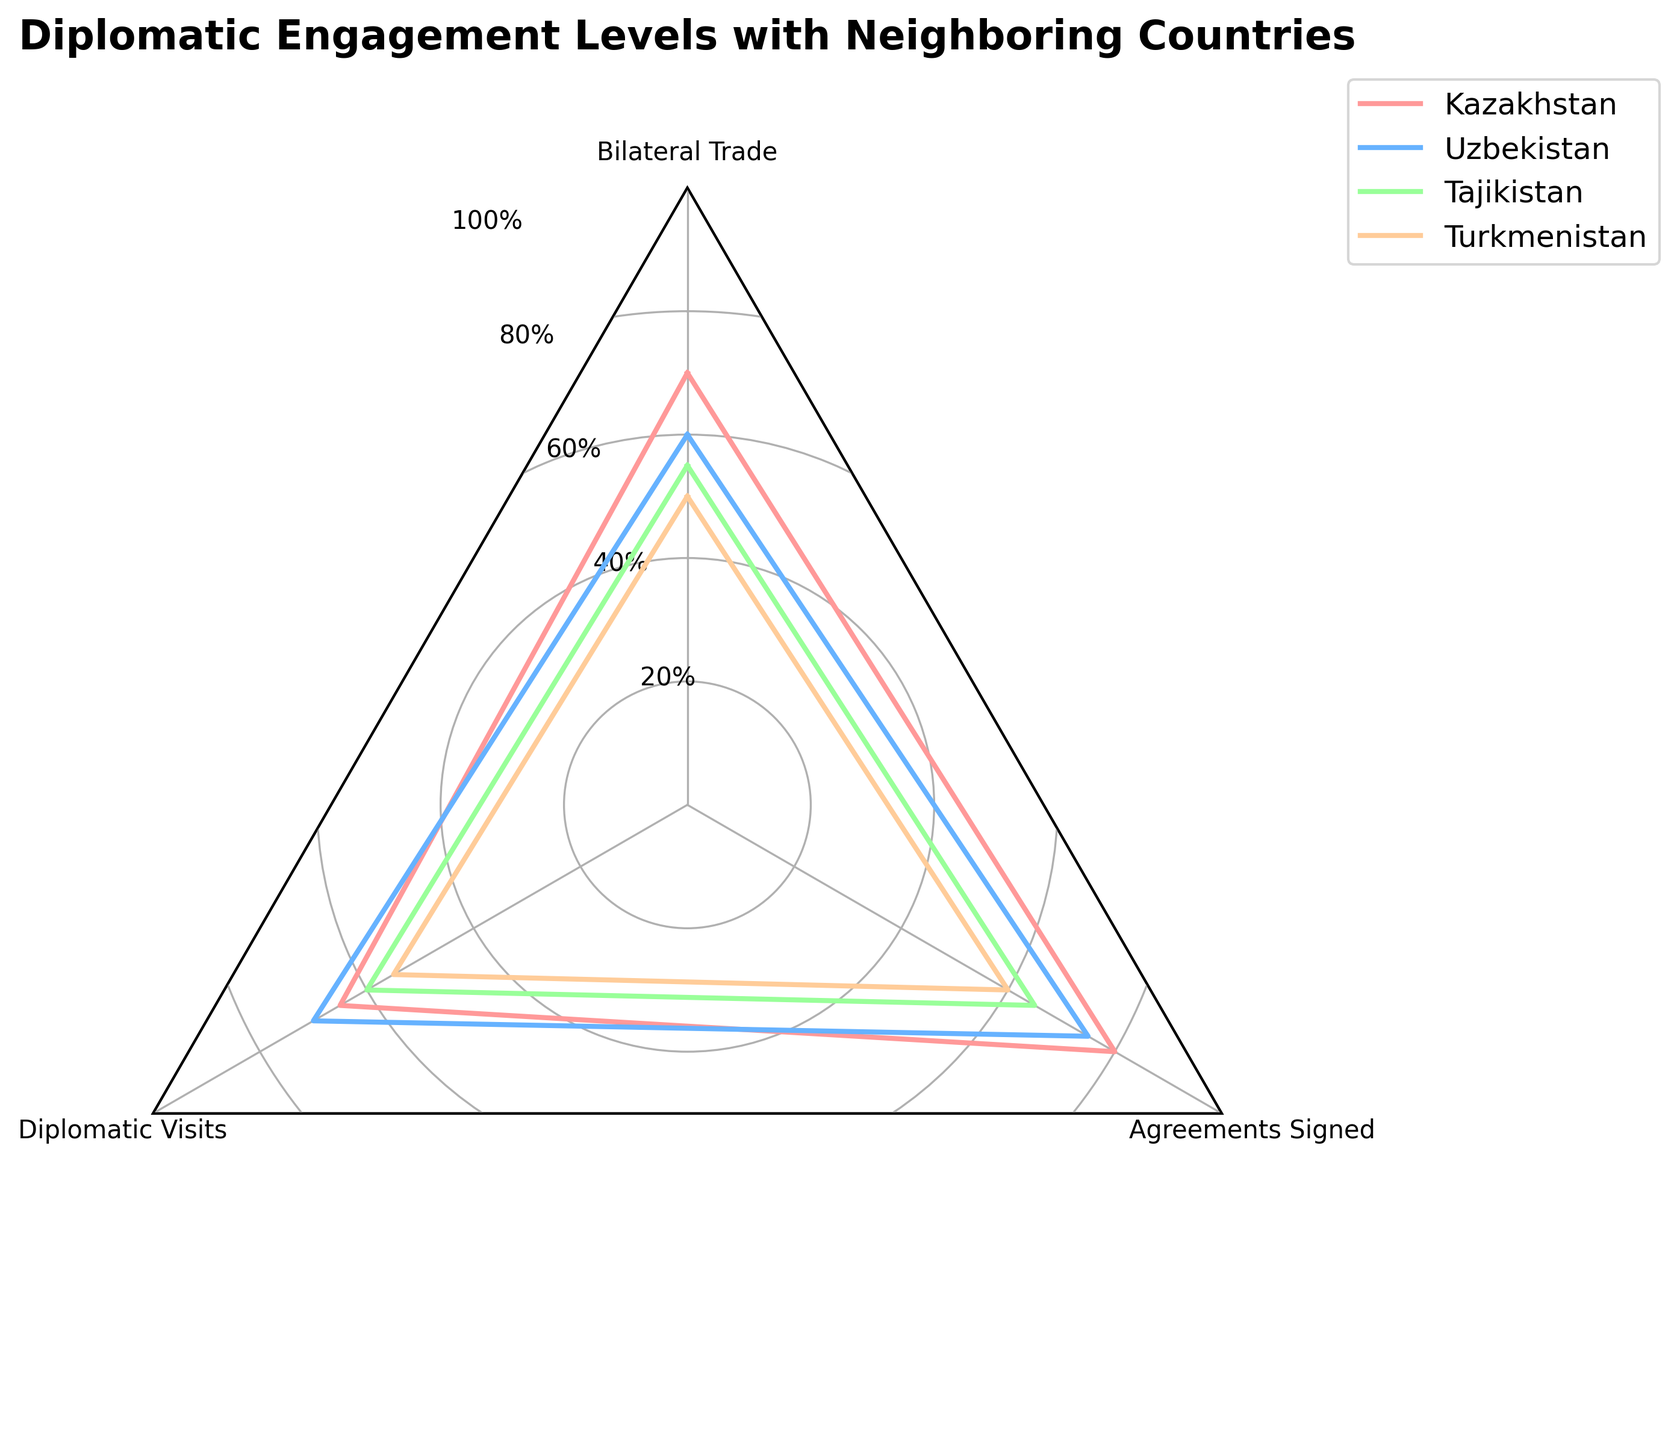What is the title of the radar chart? The title of the radar chart is usually displayed at the top center of the figure. In this case, the title reads "Diplomatic Engagement Levels with Neighboring Countries".
Answer: Diplomatic Engagement Levels with Neighboring Countries What categories are measured for each country in the figure? The categories are listed at the vertices of the radar chart. They include: Bilateral Trade, Diplomatic Visits, and Agreements Signed.
Answer: Bilateral Trade, Diplomatic Visits, Agreements Signed Which country has the highest engagement in Bilateral Trade? By looking at the point on the radar chart corresponding to Bilateral Trade and comparing the values, we see that Kazakhstan has the highest value at 70.
Answer: Kazakhstan Which country has the lowest level of Diplomatic Visits? By looking at the point on the radar chart corresponding to Diplomatic Visits, Turkmenistan has the lowest value at 55.
Answer: Turkmenistan What is the sum of Agreements Signed for Uzbekistan and Tajikistan? The radar chart shows that Uzbekistan has 75 Agreements Signed and Tajikistan has 65. Adding these values together, the sum is 75 + 65 = 140.
Answer: 140 Which country shows the most balanced diplomatic engagement across all categories? To determine balance, we look at the radar chart for the countries whose lines are closest to equidistant from the center for all categories. Uzbekistan has relatively balanced values (60, 70, 75).
Answer: Uzbekistan How does Kazakhstan's diplomatic engagement in Diplomatic Visits compare with that of Turkmenistan? By examining the Diplomatic Visits data points on the radar chart, we see that Kazakhstan has 65 and Turkmenistan has 55. Therefore, Kazakhstan's engagement in Diplomatic Visits is higher.
Answer: Kazakhstan's is higher What is the average engagement level for Tajikistan across all categories? Tajikistan's values are Bilateral Trade: 55, Diplomatic Visits: 60, and Agreements Signed: 65. The average is (55 + 60 + 65) / 3 = 60.
Answer: 60 Which country has the largest variation in engagement levels between categories? Variation is determined by the range (maximum value minus minimum value) of the data points. Kazakhstan’s range is 80 - 65 = 15, Uzbekistan's is 75 - 60 = 15, Tajikistan's is 65 - 55 = 10, and Turkmenistan's is 60 - 50 = 10. Both Kazakhstan and Uzbekistan have the largest variation of 15.
Answer: Kazakhstan and Uzbekistan 